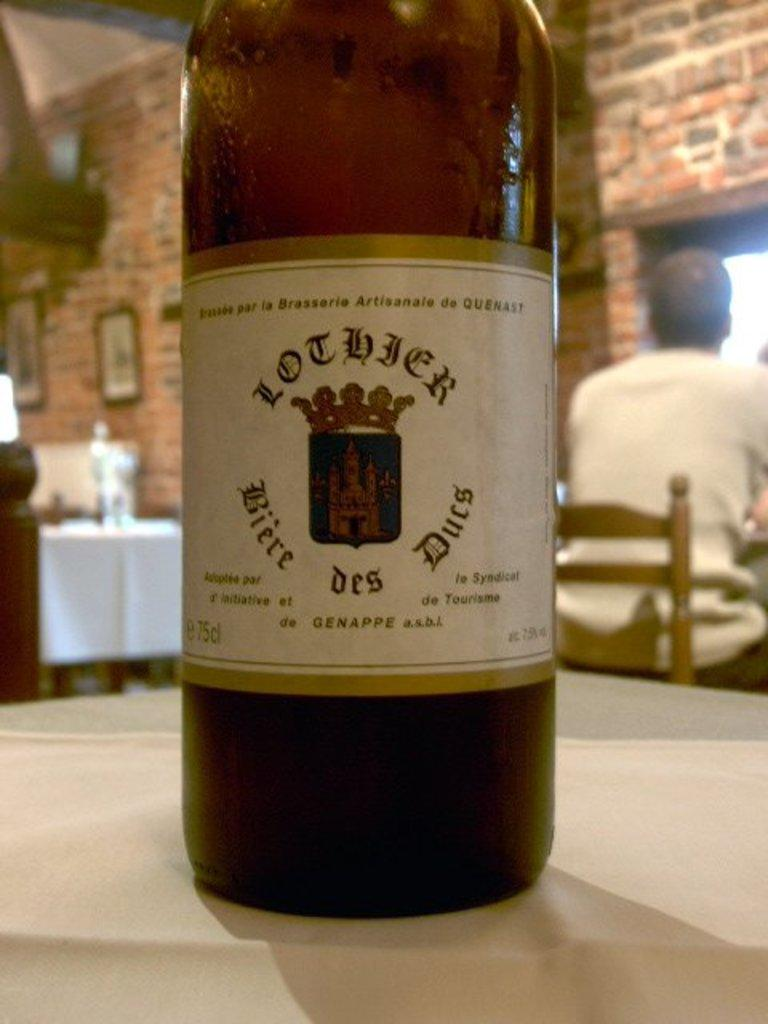What object is on the table in the foreground of the image? There is a bottle on a table in the foreground of the image. What is the man in the background of the image doing? In the background, there is a man sitting on a chair. Can you describe the setting in the background of the image? There is a table and a wall in the background of the image, with frames on the wall. What is above the man sitting in the background? There is a ceiling in the background of the image. How old is the boy sitting in the image? There is no boy present in the image. 